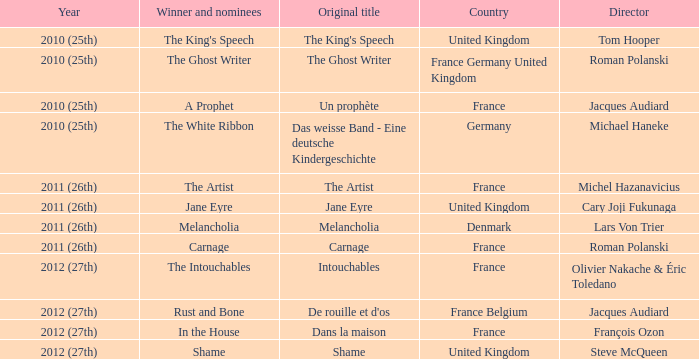What was the initial title for the king's speech? The King's Speech. 